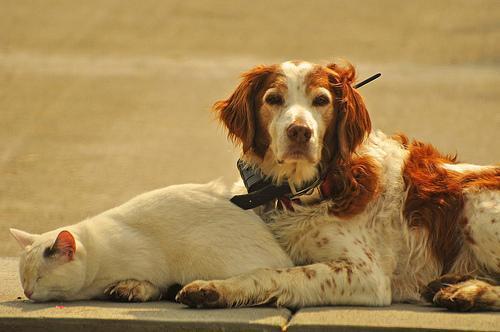How many animals are in the scene?
Give a very brief answer. 2. How many dogs are in the scene?
Give a very brief answer. 1. 